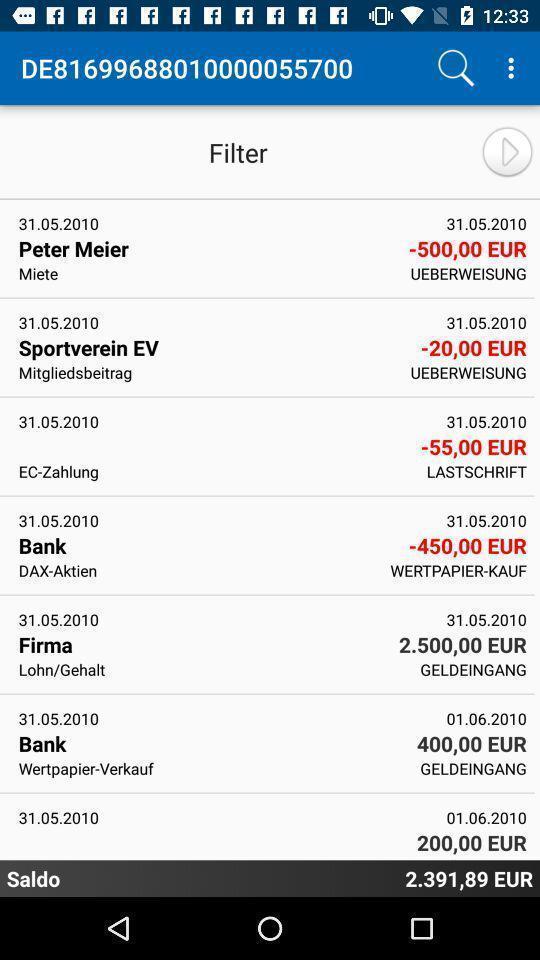Give me a narrative description of this picture. Screen page displaying various information. 